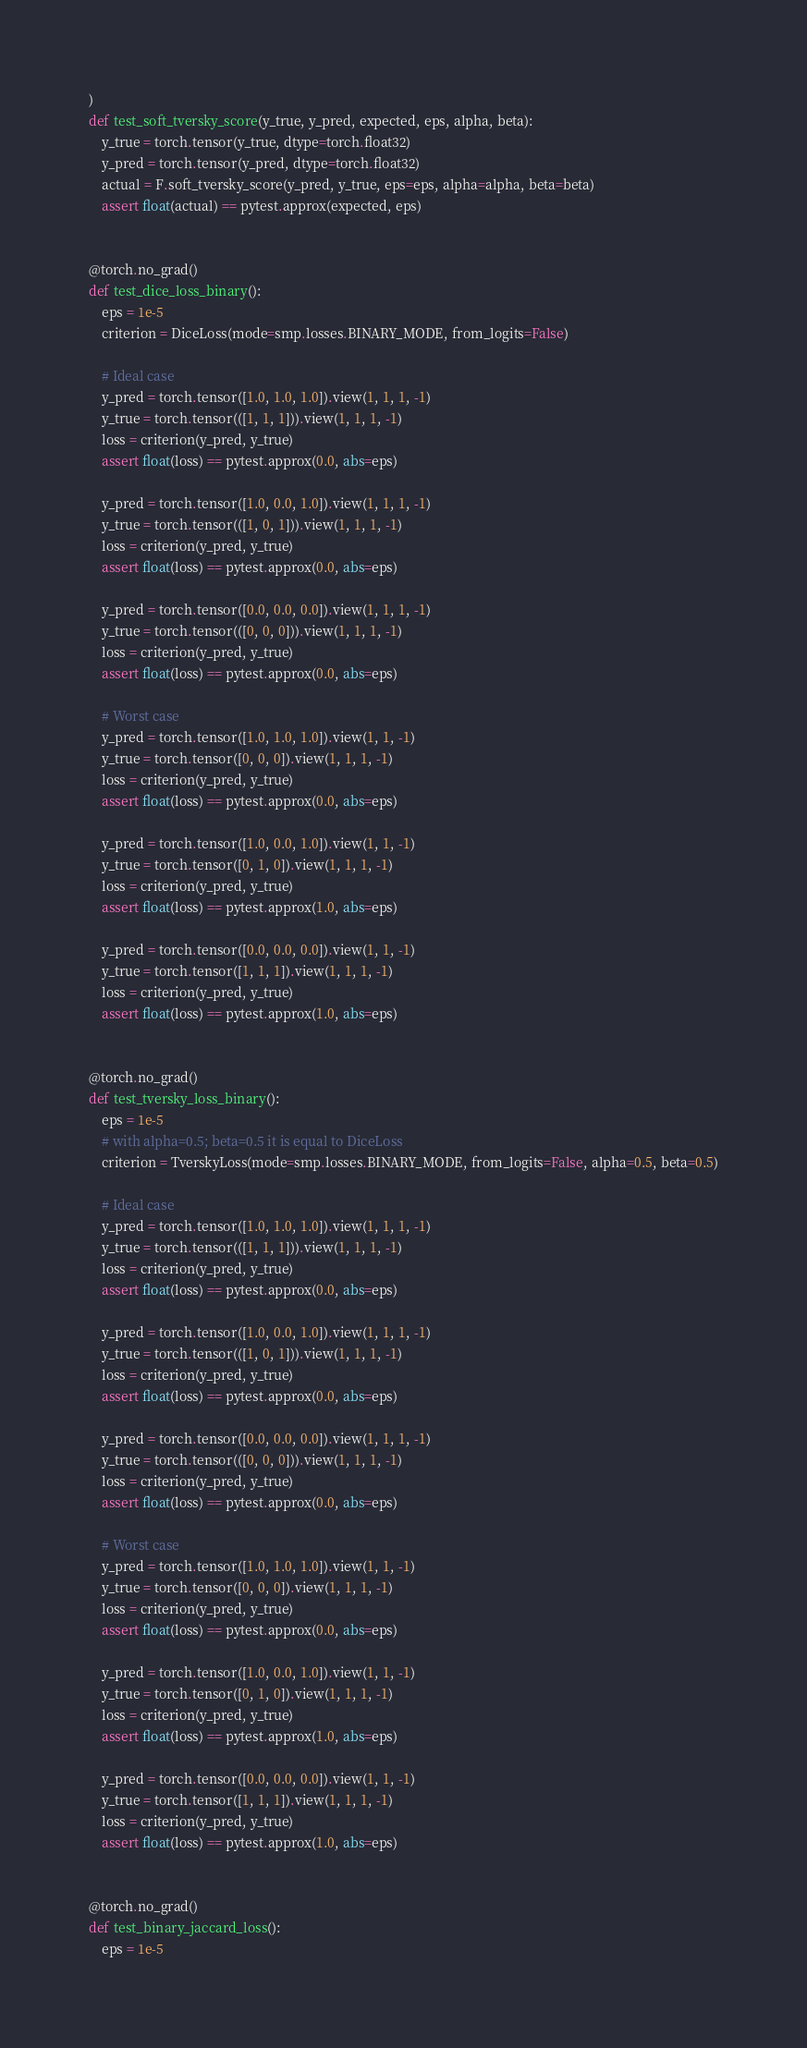<code> <loc_0><loc_0><loc_500><loc_500><_Python_>)
def test_soft_tversky_score(y_true, y_pred, expected, eps, alpha, beta):
    y_true = torch.tensor(y_true, dtype=torch.float32)
    y_pred = torch.tensor(y_pred, dtype=torch.float32)
    actual = F.soft_tversky_score(y_pred, y_true, eps=eps, alpha=alpha, beta=beta)
    assert float(actual) == pytest.approx(expected, eps)


@torch.no_grad()
def test_dice_loss_binary():
    eps = 1e-5
    criterion = DiceLoss(mode=smp.losses.BINARY_MODE, from_logits=False)

    # Ideal case
    y_pred = torch.tensor([1.0, 1.0, 1.0]).view(1, 1, 1, -1)
    y_true = torch.tensor(([1, 1, 1])).view(1, 1, 1, -1)
    loss = criterion(y_pred, y_true)
    assert float(loss) == pytest.approx(0.0, abs=eps)

    y_pred = torch.tensor([1.0, 0.0, 1.0]).view(1, 1, 1, -1)
    y_true = torch.tensor(([1, 0, 1])).view(1, 1, 1, -1)
    loss = criterion(y_pred, y_true)
    assert float(loss) == pytest.approx(0.0, abs=eps)

    y_pred = torch.tensor([0.0, 0.0, 0.0]).view(1, 1, 1, -1)
    y_true = torch.tensor(([0, 0, 0])).view(1, 1, 1, -1)
    loss = criterion(y_pred, y_true)
    assert float(loss) == pytest.approx(0.0, abs=eps)

    # Worst case
    y_pred = torch.tensor([1.0, 1.0, 1.0]).view(1, 1, -1)
    y_true = torch.tensor([0, 0, 0]).view(1, 1, 1, -1)
    loss = criterion(y_pred, y_true)
    assert float(loss) == pytest.approx(0.0, abs=eps)

    y_pred = torch.tensor([1.0, 0.0, 1.0]).view(1, 1, -1)
    y_true = torch.tensor([0, 1, 0]).view(1, 1, 1, -1)
    loss = criterion(y_pred, y_true)
    assert float(loss) == pytest.approx(1.0, abs=eps)

    y_pred = torch.tensor([0.0, 0.0, 0.0]).view(1, 1, -1)
    y_true = torch.tensor([1, 1, 1]).view(1, 1, 1, -1)
    loss = criterion(y_pred, y_true)
    assert float(loss) == pytest.approx(1.0, abs=eps)


@torch.no_grad()
def test_tversky_loss_binary():
    eps = 1e-5
    # with alpha=0.5; beta=0.5 it is equal to DiceLoss
    criterion = TverskyLoss(mode=smp.losses.BINARY_MODE, from_logits=False, alpha=0.5, beta=0.5)

    # Ideal case
    y_pred = torch.tensor([1.0, 1.0, 1.0]).view(1, 1, 1, -1)
    y_true = torch.tensor(([1, 1, 1])).view(1, 1, 1, -1)
    loss = criterion(y_pred, y_true)
    assert float(loss) == pytest.approx(0.0, abs=eps)

    y_pred = torch.tensor([1.0, 0.0, 1.0]).view(1, 1, 1, -1)
    y_true = torch.tensor(([1, 0, 1])).view(1, 1, 1, -1)
    loss = criterion(y_pred, y_true)
    assert float(loss) == pytest.approx(0.0, abs=eps)

    y_pred = torch.tensor([0.0, 0.0, 0.0]).view(1, 1, 1, -1)
    y_true = torch.tensor(([0, 0, 0])).view(1, 1, 1, -1)
    loss = criterion(y_pred, y_true)
    assert float(loss) == pytest.approx(0.0, abs=eps)

    # Worst case
    y_pred = torch.tensor([1.0, 1.0, 1.0]).view(1, 1, -1)
    y_true = torch.tensor([0, 0, 0]).view(1, 1, 1, -1)
    loss = criterion(y_pred, y_true)
    assert float(loss) == pytest.approx(0.0, abs=eps)

    y_pred = torch.tensor([1.0, 0.0, 1.0]).view(1, 1, -1)
    y_true = torch.tensor([0, 1, 0]).view(1, 1, 1, -1)
    loss = criterion(y_pred, y_true)
    assert float(loss) == pytest.approx(1.0, abs=eps)

    y_pred = torch.tensor([0.0, 0.0, 0.0]).view(1, 1, -1)
    y_true = torch.tensor([1, 1, 1]).view(1, 1, 1, -1)
    loss = criterion(y_pred, y_true)
    assert float(loss) == pytest.approx(1.0, abs=eps)


@torch.no_grad()
def test_binary_jaccard_loss():
    eps = 1e-5</code> 